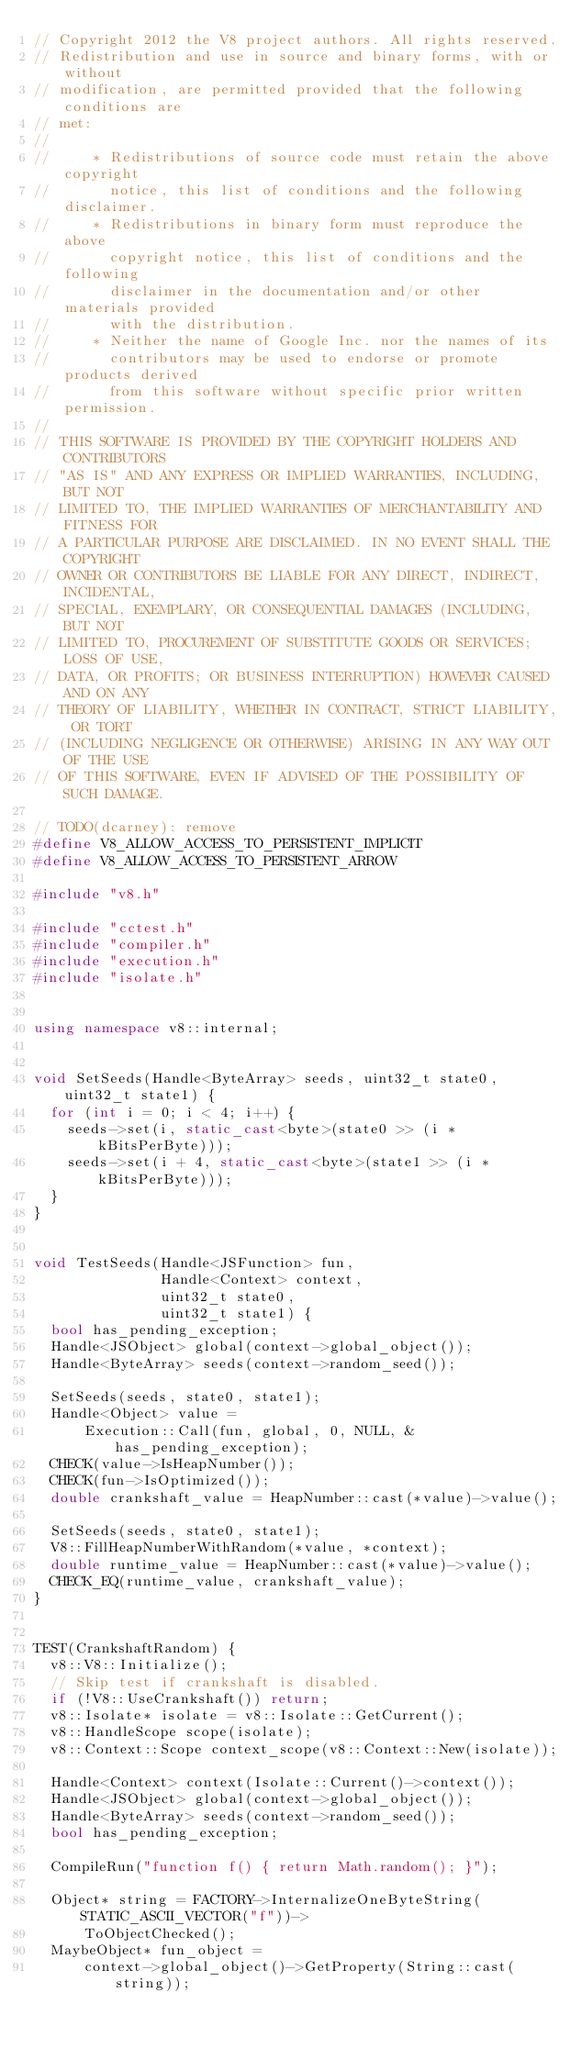<code> <loc_0><loc_0><loc_500><loc_500><_C++_>// Copyright 2012 the V8 project authors. All rights reserved.
// Redistribution and use in source and binary forms, with or without
// modification, are permitted provided that the following conditions are
// met:
//
//     * Redistributions of source code must retain the above copyright
//       notice, this list of conditions and the following disclaimer.
//     * Redistributions in binary form must reproduce the above
//       copyright notice, this list of conditions and the following
//       disclaimer in the documentation and/or other materials provided
//       with the distribution.
//     * Neither the name of Google Inc. nor the names of its
//       contributors may be used to endorse or promote products derived
//       from this software without specific prior written permission.
//
// THIS SOFTWARE IS PROVIDED BY THE COPYRIGHT HOLDERS AND CONTRIBUTORS
// "AS IS" AND ANY EXPRESS OR IMPLIED WARRANTIES, INCLUDING, BUT NOT
// LIMITED TO, THE IMPLIED WARRANTIES OF MERCHANTABILITY AND FITNESS FOR
// A PARTICULAR PURPOSE ARE DISCLAIMED. IN NO EVENT SHALL THE COPYRIGHT
// OWNER OR CONTRIBUTORS BE LIABLE FOR ANY DIRECT, INDIRECT, INCIDENTAL,
// SPECIAL, EXEMPLARY, OR CONSEQUENTIAL DAMAGES (INCLUDING, BUT NOT
// LIMITED TO, PROCUREMENT OF SUBSTITUTE GOODS OR SERVICES; LOSS OF USE,
// DATA, OR PROFITS; OR BUSINESS INTERRUPTION) HOWEVER CAUSED AND ON ANY
// THEORY OF LIABILITY, WHETHER IN CONTRACT, STRICT LIABILITY, OR TORT
// (INCLUDING NEGLIGENCE OR OTHERWISE) ARISING IN ANY WAY OUT OF THE USE
// OF THIS SOFTWARE, EVEN IF ADVISED OF THE POSSIBILITY OF SUCH DAMAGE.

// TODO(dcarney): remove
#define V8_ALLOW_ACCESS_TO_PERSISTENT_IMPLICIT
#define V8_ALLOW_ACCESS_TO_PERSISTENT_ARROW

#include "v8.h"

#include "cctest.h"
#include "compiler.h"
#include "execution.h"
#include "isolate.h"


using namespace v8::internal;


void SetSeeds(Handle<ByteArray> seeds, uint32_t state0, uint32_t state1) {
  for (int i = 0; i < 4; i++) {
    seeds->set(i, static_cast<byte>(state0 >> (i * kBitsPerByte)));
    seeds->set(i + 4, static_cast<byte>(state1 >> (i * kBitsPerByte)));
  }
}


void TestSeeds(Handle<JSFunction> fun,
               Handle<Context> context,
               uint32_t state0,
               uint32_t state1) {
  bool has_pending_exception;
  Handle<JSObject> global(context->global_object());
  Handle<ByteArray> seeds(context->random_seed());

  SetSeeds(seeds, state0, state1);
  Handle<Object> value =
      Execution::Call(fun, global, 0, NULL, &has_pending_exception);
  CHECK(value->IsHeapNumber());
  CHECK(fun->IsOptimized());
  double crankshaft_value = HeapNumber::cast(*value)->value();

  SetSeeds(seeds, state0, state1);
  V8::FillHeapNumberWithRandom(*value, *context);
  double runtime_value = HeapNumber::cast(*value)->value();
  CHECK_EQ(runtime_value, crankshaft_value);
}


TEST(CrankshaftRandom) {
  v8::V8::Initialize();
  // Skip test if crankshaft is disabled.
  if (!V8::UseCrankshaft()) return;
  v8::Isolate* isolate = v8::Isolate::GetCurrent();
  v8::HandleScope scope(isolate);
  v8::Context::Scope context_scope(v8::Context::New(isolate));

  Handle<Context> context(Isolate::Current()->context());
  Handle<JSObject> global(context->global_object());
  Handle<ByteArray> seeds(context->random_seed());
  bool has_pending_exception;

  CompileRun("function f() { return Math.random(); }");

  Object* string = FACTORY->InternalizeOneByteString(STATIC_ASCII_VECTOR("f"))->
      ToObjectChecked();
  MaybeObject* fun_object =
      context->global_object()->GetProperty(String::cast(string));</code> 